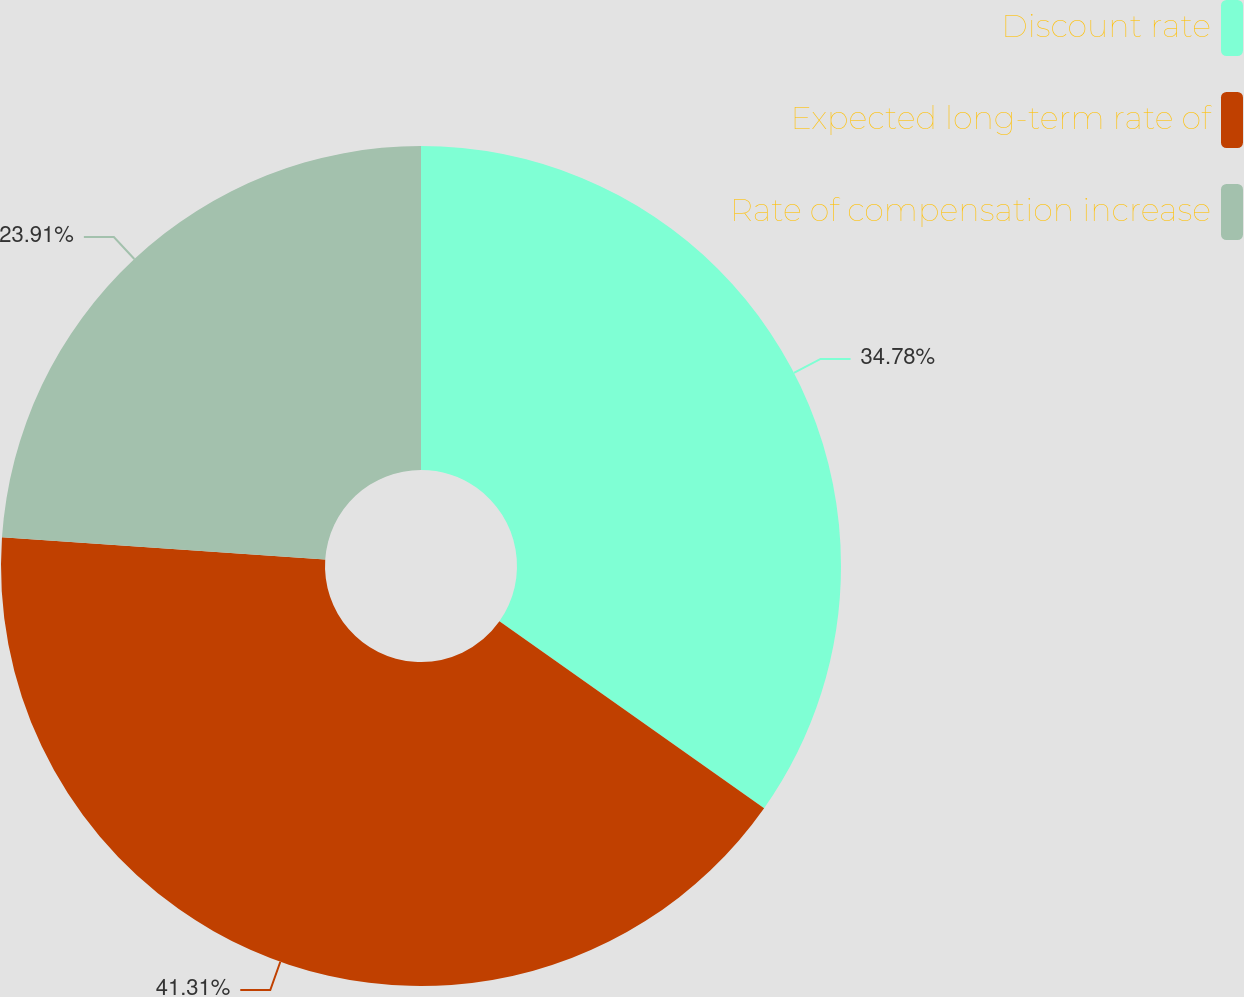<chart> <loc_0><loc_0><loc_500><loc_500><pie_chart><fcel>Discount rate<fcel>Expected long-term rate of<fcel>Rate of compensation increase<nl><fcel>34.78%<fcel>41.3%<fcel>23.91%<nl></chart> 